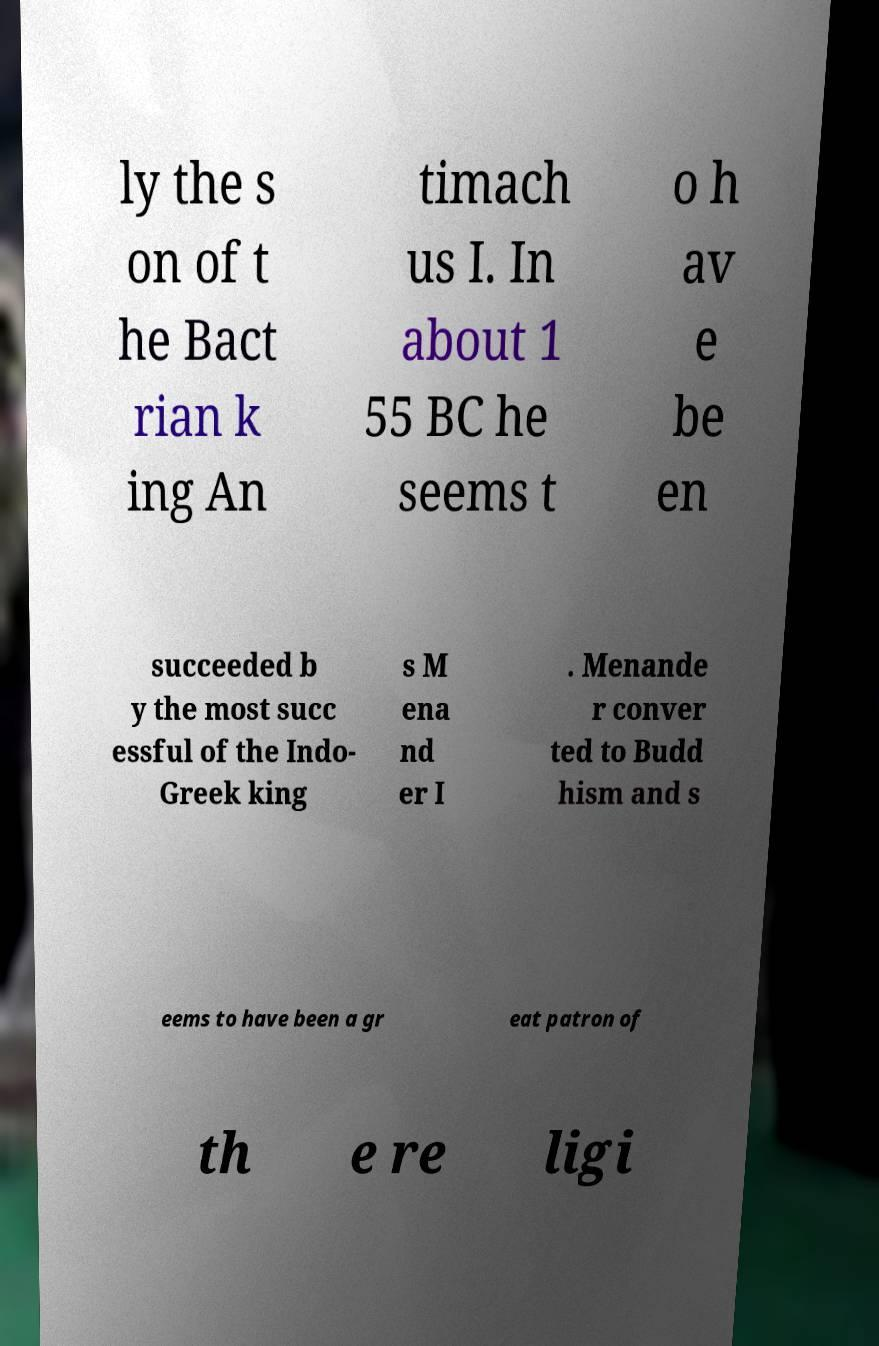Could you extract and type out the text from this image? ly the s on of t he Bact rian k ing An timach us I. In about 1 55 BC he seems t o h av e be en succeeded b y the most succ essful of the Indo- Greek king s M ena nd er I . Menande r conver ted to Budd hism and s eems to have been a gr eat patron of th e re ligi 